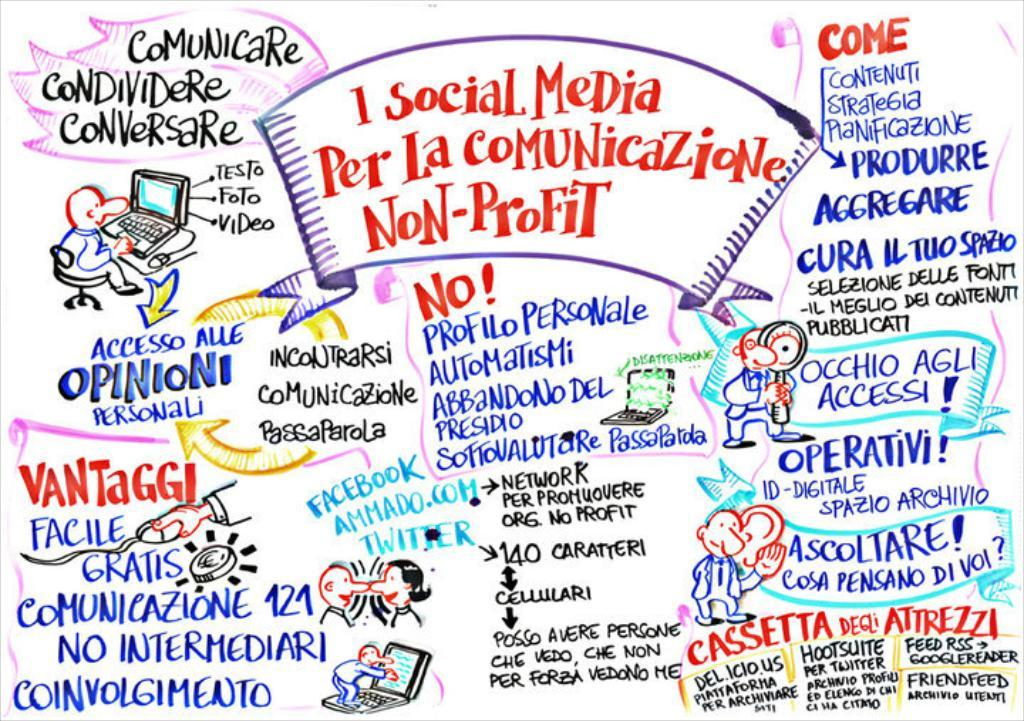What can be found in the image that contains written information? There is some text in the image. Who or what is present in the image besides the text? There are people and figures in the image. What type of train can be seen in the image? There is no train present in the image. What subject is being taught in the image? There is no teaching or educational activity depicted in the image. 